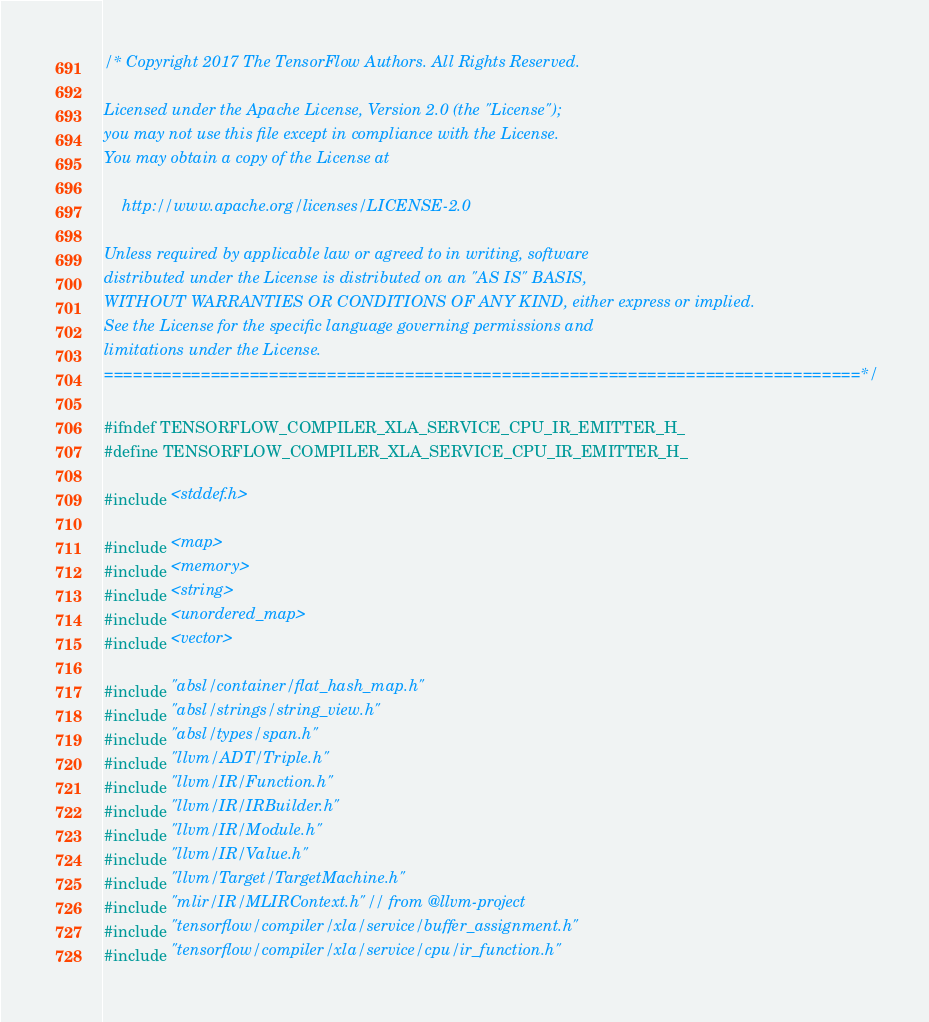<code> <loc_0><loc_0><loc_500><loc_500><_C_>/* Copyright 2017 The TensorFlow Authors. All Rights Reserved.

Licensed under the Apache License, Version 2.0 (the "License");
you may not use this file except in compliance with the License.
You may obtain a copy of the License at

    http://www.apache.org/licenses/LICENSE-2.0

Unless required by applicable law or agreed to in writing, software
distributed under the License is distributed on an "AS IS" BASIS,
WITHOUT WARRANTIES OR CONDITIONS OF ANY KIND, either express or implied.
See the License for the specific language governing permissions and
limitations under the License.
==============================================================================*/

#ifndef TENSORFLOW_COMPILER_XLA_SERVICE_CPU_IR_EMITTER_H_
#define TENSORFLOW_COMPILER_XLA_SERVICE_CPU_IR_EMITTER_H_

#include <stddef.h>

#include <map>
#include <memory>
#include <string>
#include <unordered_map>
#include <vector>

#include "absl/container/flat_hash_map.h"
#include "absl/strings/string_view.h"
#include "absl/types/span.h"
#include "llvm/ADT/Triple.h"
#include "llvm/IR/Function.h"
#include "llvm/IR/IRBuilder.h"
#include "llvm/IR/Module.h"
#include "llvm/IR/Value.h"
#include "llvm/Target/TargetMachine.h"
#include "mlir/IR/MLIRContext.h"  // from @llvm-project
#include "tensorflow/compiler/xla/service/buffer_assignment.h"
#include "tensorflow/compiler/xla/service/cpu/ir_function.h"</code> 